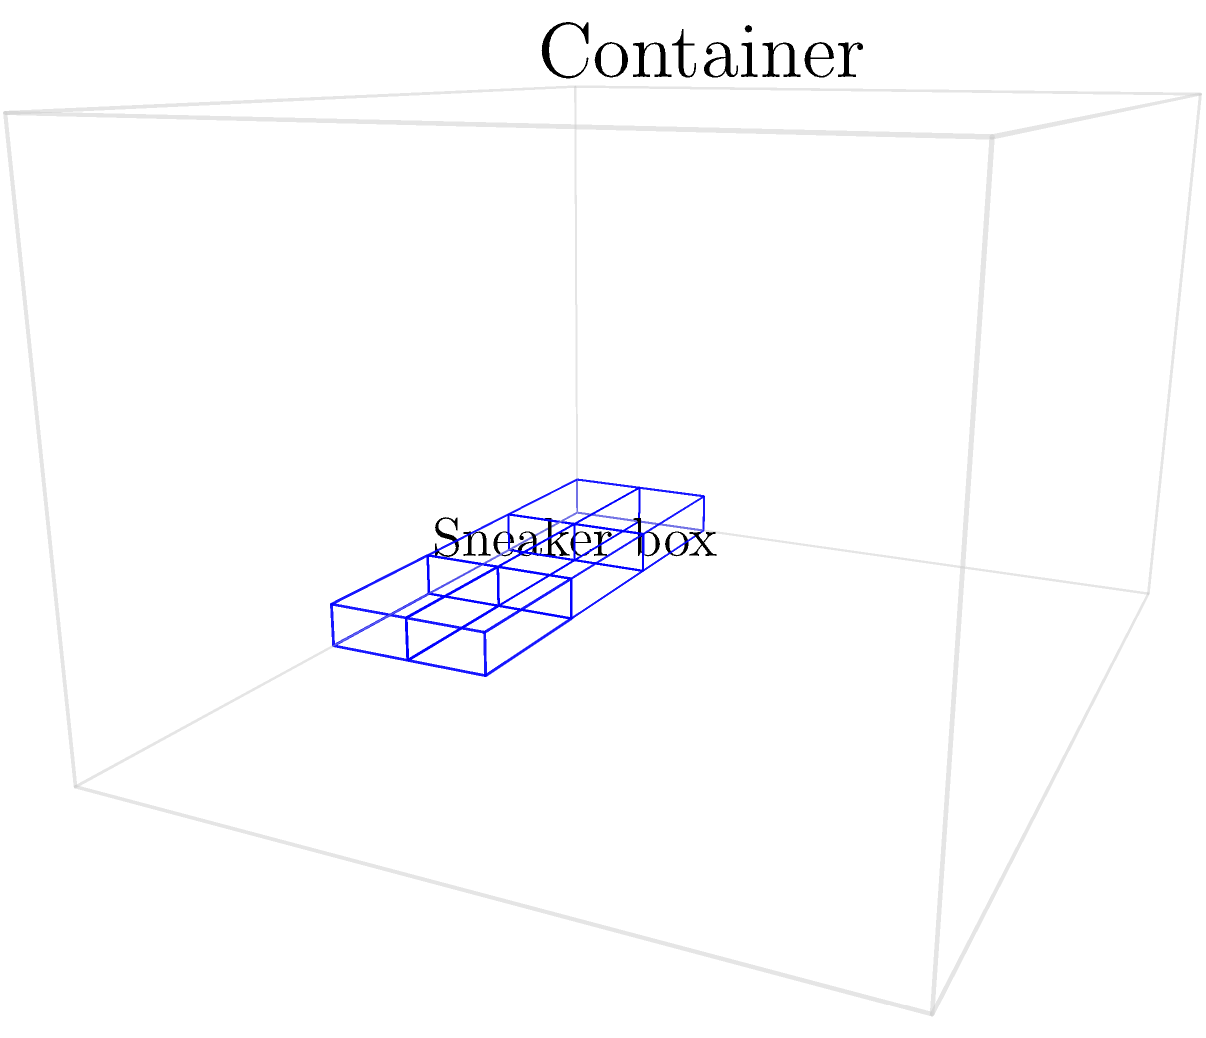A shipping container measures $10\text{ ft} \times 8\text{ ft} \times 6\text{ ft}$ (length $\times$ width $\times$ height). Each sneaker box is a rectangular prism measuring $24\text{ in} \times 12\text{ in} \times 6\text{ in}$. What is the maximum number of sneaker boxes that can be packed into the shipping container? To solve this problem, we need to follow these steps:

1. Convert all measurements to the same unit (inches):
   Container: $120\text{ in} \times 96\text{ in} \times 72\text{ in}$
   Sneaker box: $24\text{ in} \times 12\text{ in} \times 6\text{ in}$

2. Calculate the number of sneaker boxes that can fit in each dimension:
   Length: $120 \div 24 = 5$ boxes
   Width: $96 \div 12 = 8$ boxes
   Height: $72 \div 6 = 12$ boxes

3. Multiply the number of boxes in each dimension:
   $5 \times 8 \times 12 = 480$ boxes

Therefore, the maximum number of sneaker boxes that can be packed into the shipping container is 480.

Note: This solution assumes perfect packing efficiency and does not account for any space needed for handling or air circulation.
Answer: 480 boxes 